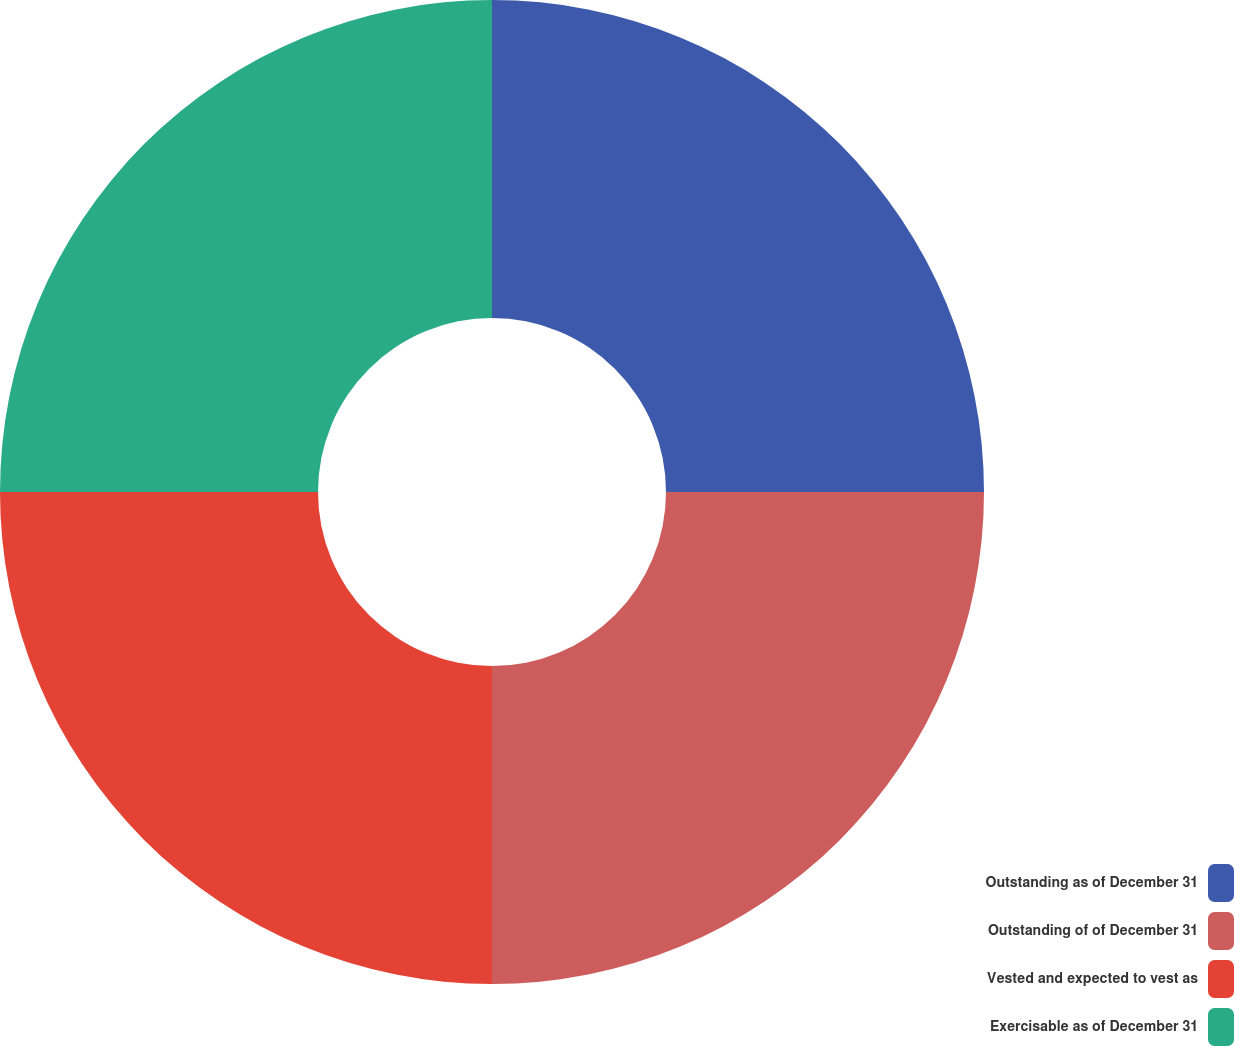Convert chart. <chart><loc_0><loc_0><loc_500><loc_500><pie_chart><fcel>Outstanding as of December 31<fcel>Outstanding of of December 31<fcel>Vested and expected to vest as<fcel>Exercisable as of December 31<nl><fcel>25.0%<fcel>25.0%<fcel>25.0%<fcel>25.0%<nl></chart> 